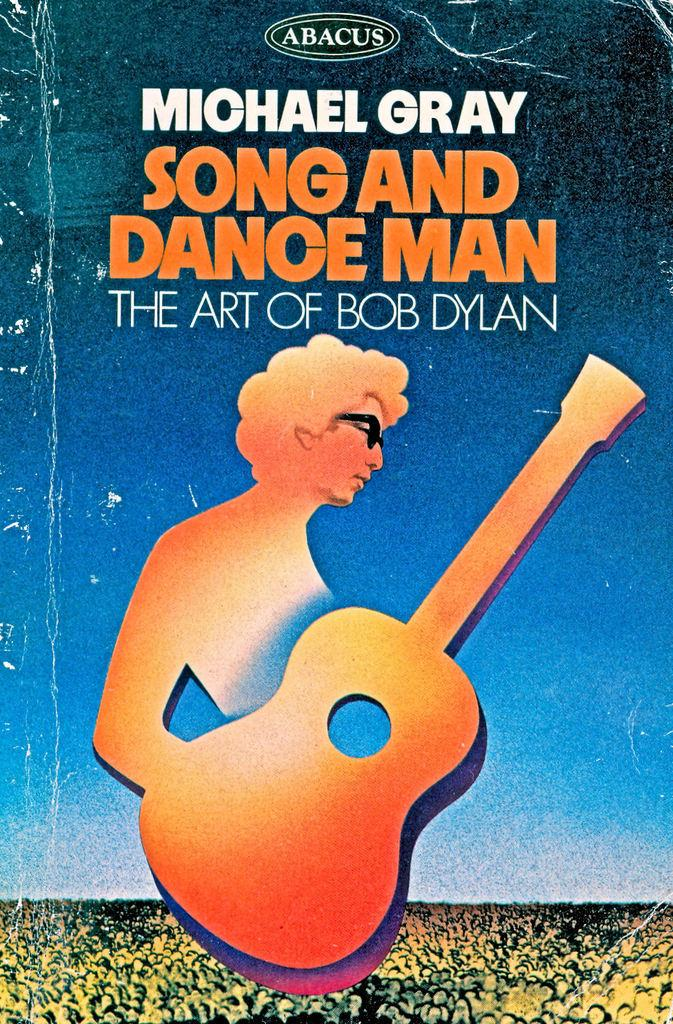What type of visual is the image? The image is a poster. What object is featured in the poster? There is a guitar in the poster. What is the person in the poster wearing? The person is wearing goggles in the poster. Are there any words or phrases in the poster? Yes, there is text in the poster. How many eggs are being carried by the person in the poster? There are no eggs present in the poster; the person is wearing goggles. What type of journey is the person in the poster taking? There is no indication of a journey in the poster; it features a guitar and a person wearing goggles. 